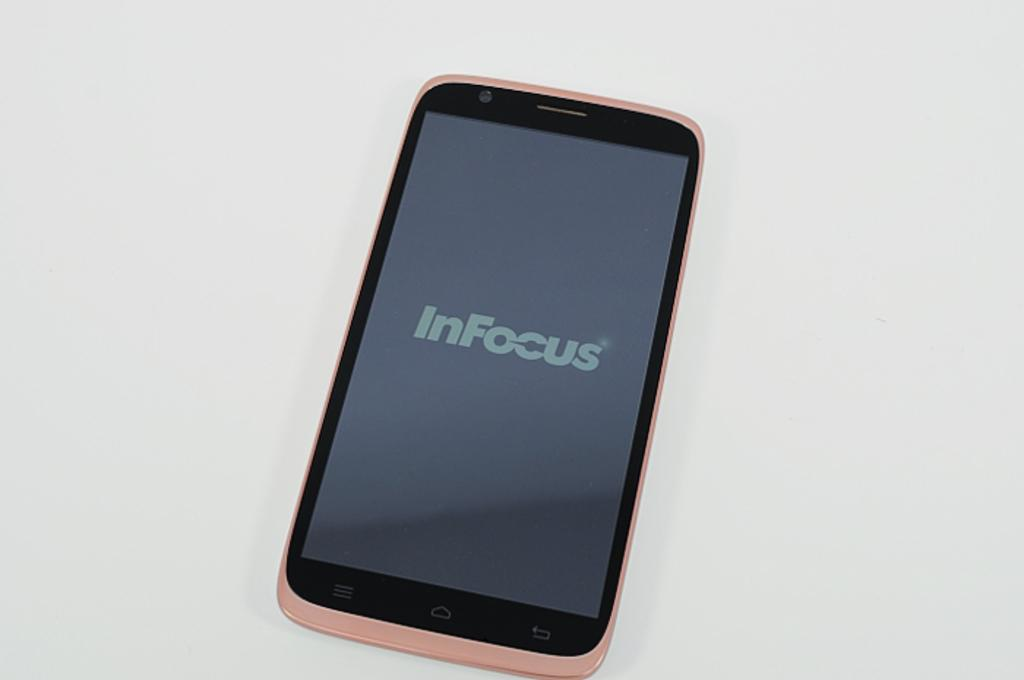<image>
Write a terse but informative summary of the picture. A pink cell phone has In Focus displayed on the screen. 